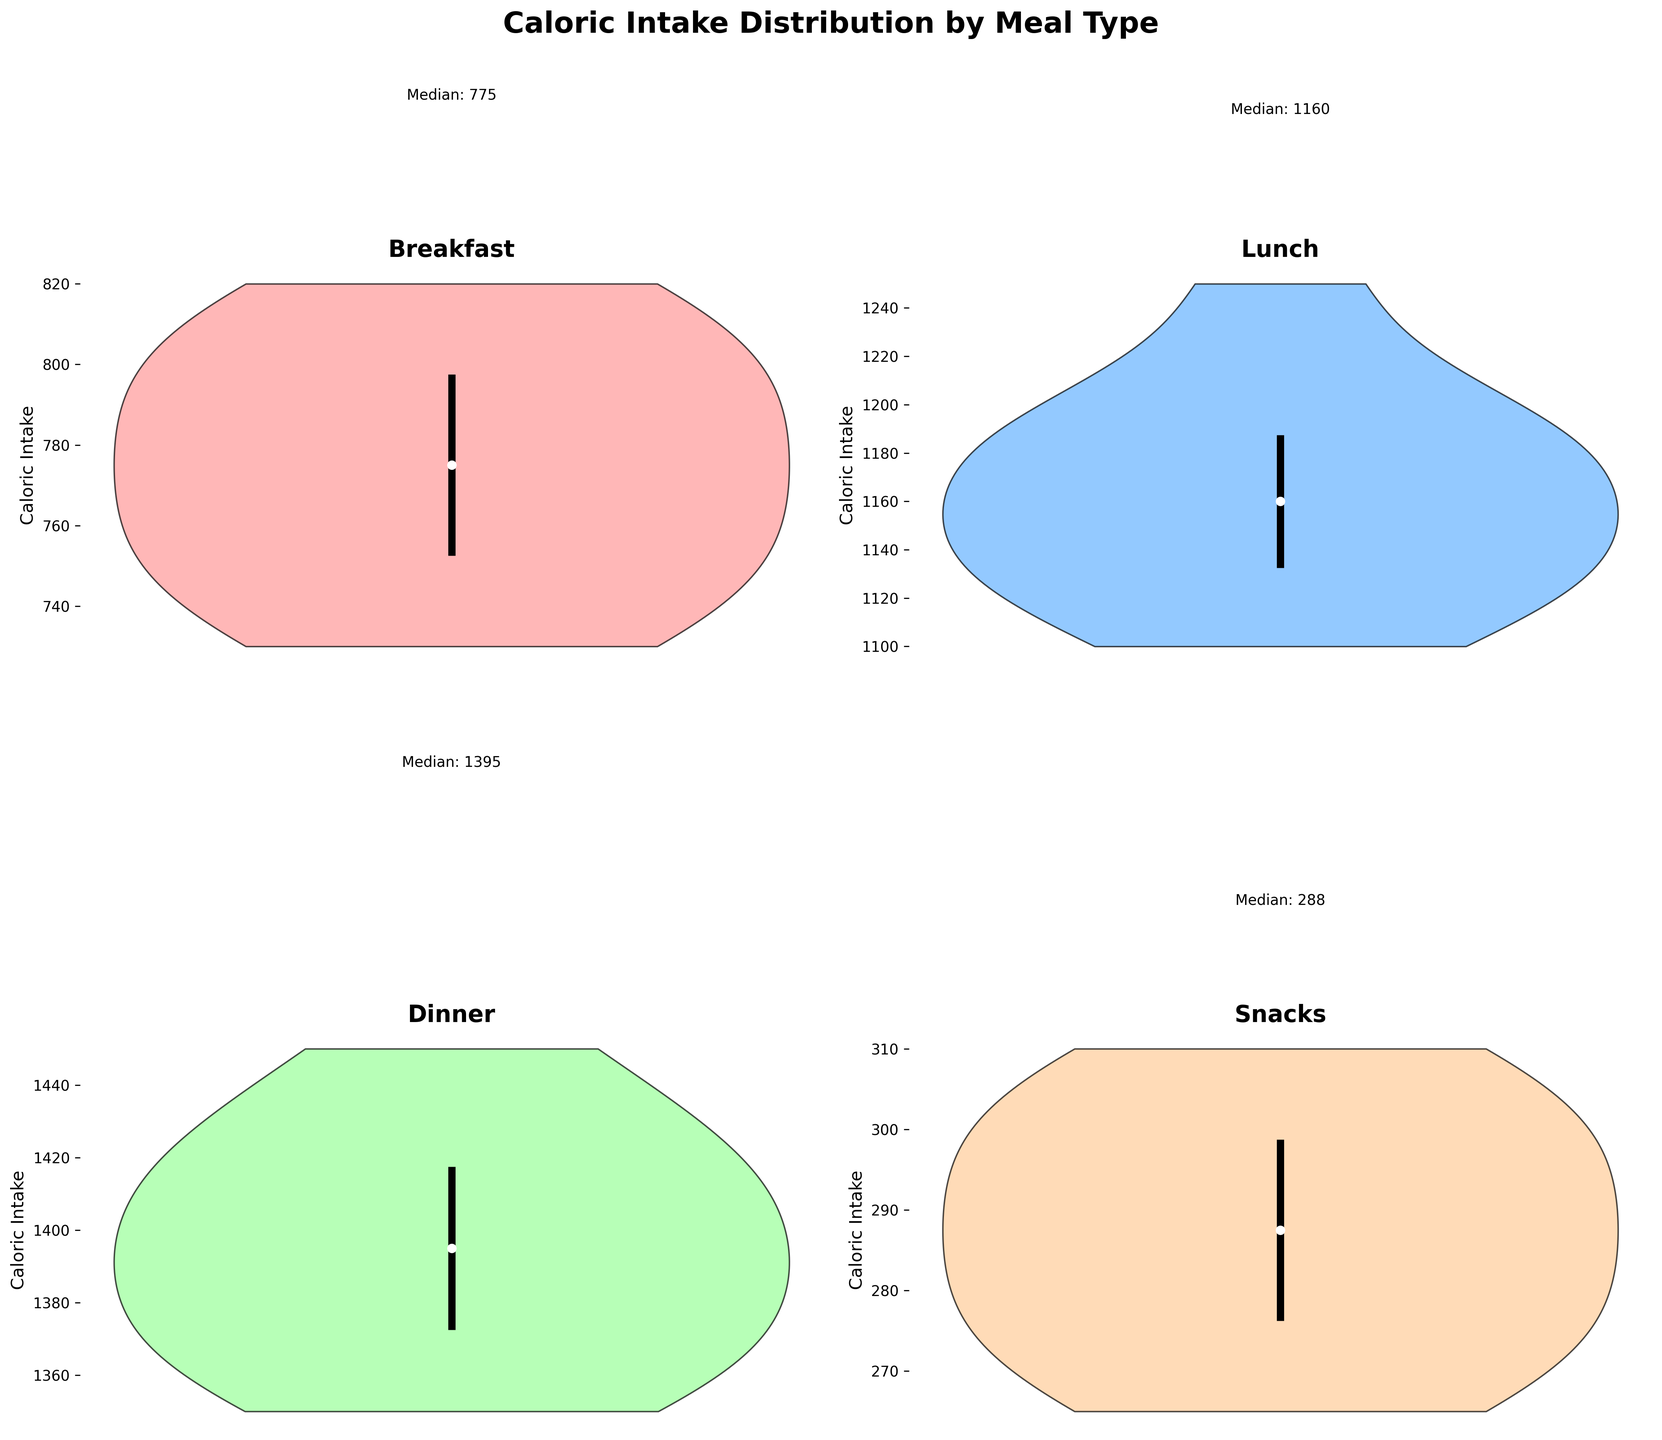What's the title of the figure? The title is visible at the top of the figure and is written in bold, large font.
Answer: Caloric Intake Distribution by Meal Type Which meal type shows the lowest caloric intake? By visually comparing the central tendencies on each subplot, the Snacks category has the lowest values.
Answer: Snacks What is the median caloric intake for lunch? The median value for each subplot is marked by a white circle; the Lunch subplot shows an annotation indicating 'Median: 1175'.
Answer: 1175 Which meal type has the highest median caloric intake? By looking at the annotations above each subplot, Dinner has the highest median value labeled.
Answer: Dinner How do the median values of breakfast and dinner compare? Checking the median annotations, Breakfast has a median of 780, while Dinner has a median of 1400.
Answer: Dinner's median is higher What is the range between the 25th and 75th percentiles for dinner? The vertical lines inside each violin plot indicate this range. For Dinner, we see the values of quartile1 and quartile3 are marked; looking at these, we can estimate the range as approximately 1375 to 1425.
Answer: 50 Which meal type has the smallest spread in caloric intake? The spread is indicated by the width of the violin plot. Snacks have the narrowest plot, indicating the smallest spread.
Answer: Snacks Which meal types have a median caloric intake below 800? By looking at the median annotations, Breakfast and Snacks have medians below 800.
Answer: Breakfast and Snacks What does the white circle inside each violin plot indicate? The white circles mark the median values of the respective caloric intake distributions.
Answer: Median Which meal type shows the most symmetrical distribution? By observing the shapes of the violin plots, Lunch appears to have the most symmetrical distribution.
Answer: Lunch 